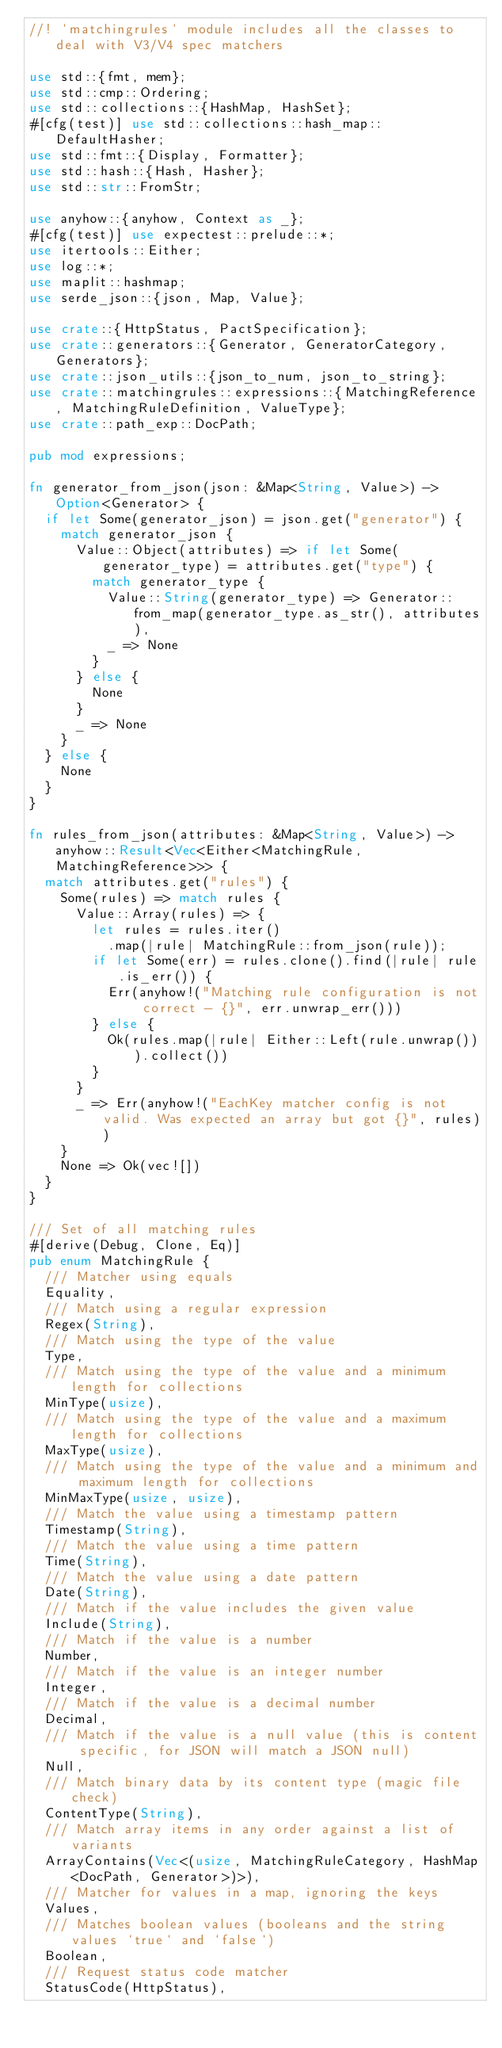<code> <loc_0><loc_0><loc_500><loc_500><_Rust_>//! `matchingrules` module includes all the classes to deal with V3/V4 spec matchers

use std::{fmt, mem};
use std::cmp::Ordering;
use std::collections::{HashMap, HashSet};
#[cfg(test)] use std::collections::hash_map::DefaultHasher;
use std::fmt::{Display, Formatter};
use std::hash::{Hash, Hasher};
use std::str::FromStr;

use anyhow::{anyhow, Context as _};
#[cfg(test)] use expectest::prelude::*;
use itertools::Either;
use log::*;
use maplit::hashmap;
use serde_json::{json, Map, Value};

use crate::{HttpStatus, PactSpecification};
use crate::generators::{Generator, GeneratorCategory, Generators};
use crate::json_utils::{json_to_num, json_to_string};
use crate::matchingrules::expressions::{MatchingReference, MatchingRuleDefinition, ValueType};
use crate::path_exp::DocPath;

pub mod expressions;

fn generator_from_json(json: &Map<String, Value>) -> Option<Generator> {
  if let Some(generator_json) = json.get("generator") {
    match generator_json {
      Value::Object(attributes) => if let Some(generator_type) = attributes.get("type") {
        match generator_type {
          Value::String(generator_type) => Generator::from_map(generator_type.as_str(), attributes),
          _ => None
        }
      } else {
        None
      }
      _ => None
    }
  } else {
    None
  }
}

fn rules_from_json(attributes: &Map<String, Value>) -> anyhow::Result<Vec<Either<MatchingRule, MatchingReference>>> {
  match attributes.get("rules") {
    Some(rules) => match rules {
      Value::Array(rules) => {
        let rules = rules.iter()
          .map(|rule| MatchingRule::from_json(rule));
        if let Some(err) = rules.clone().find(|rule| rule.is_err()) {
          Err(anyhow!("Matching rule configuration is not correct - {}", err.unwrap_err()))
        } else {
          Ok(rules.map(|rule| Either::Left(rule.unwrap())).collect())
        }
      }
      _ => Err(anyhow!("EachKey matcher config is not valid. Was expected an array but got {}", rules))
    }
    None => Ok(vec![])
  }
}

/// Set of all matching rules
#[derive(Debug, Clone, Eq)]
pub enum MatchingRule {
  /// Matcher using equals
  Equality,
  /// Match using a regular expression
  Regex(String),
  /// Match using the type of the value
  Type,
  /// Match using the type of the value and a minimum length for collections
  MinType(usize),
  /// Match using the type of the value and a maximum length for collections
  MaxType(usize),
  /// Match using the type of the value and a minimum and maximum length for collections
  MinMaxType(usize, usize),
  /// Match the value using a timestamp pattern
  Timestamp(String),
  /// Match the value using a time pattern
  Time(String),
  /// Match the value using a date pattern
  Date(String),
  /// Match if the value includes the given value
  Include(String),
  /// Match if the value is a number
  Number,
  /// Match if the value is an integer number
  Integer,
  /// Match if the value is a decimal number
  Decimal,
  /// Match if the value is a null value (this is content specific, for JSON will match a JSON null)
  Null,
  /// Match binary data by its content type (magic file check)
  ContentType(String),
  /// Match array items in any order against a list of variants
  ArrayContains(Vec<(usize, MatchingRuleCategory, HashMap<DocPath, Generator>)>),
  /// Matcher for values in a map, ignoring the keys
  Values,
  /// Matches boolean values (booleans and the string values `true` and `false`)
  Boolean,
  /// Request status code matcher
  StatusCode(HttpStatus),</code> 